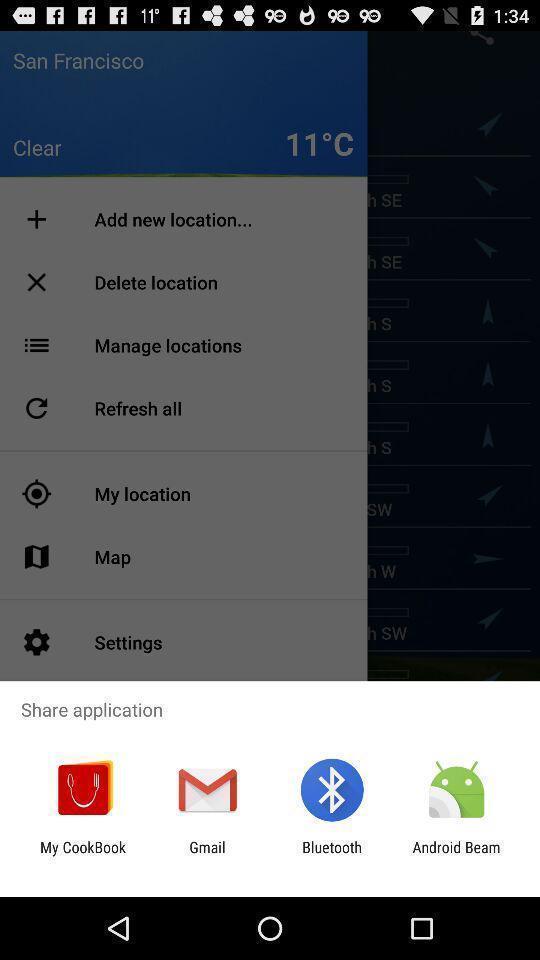Summarize the information in this screenshot. Pop-up asking to share application via different apps. 